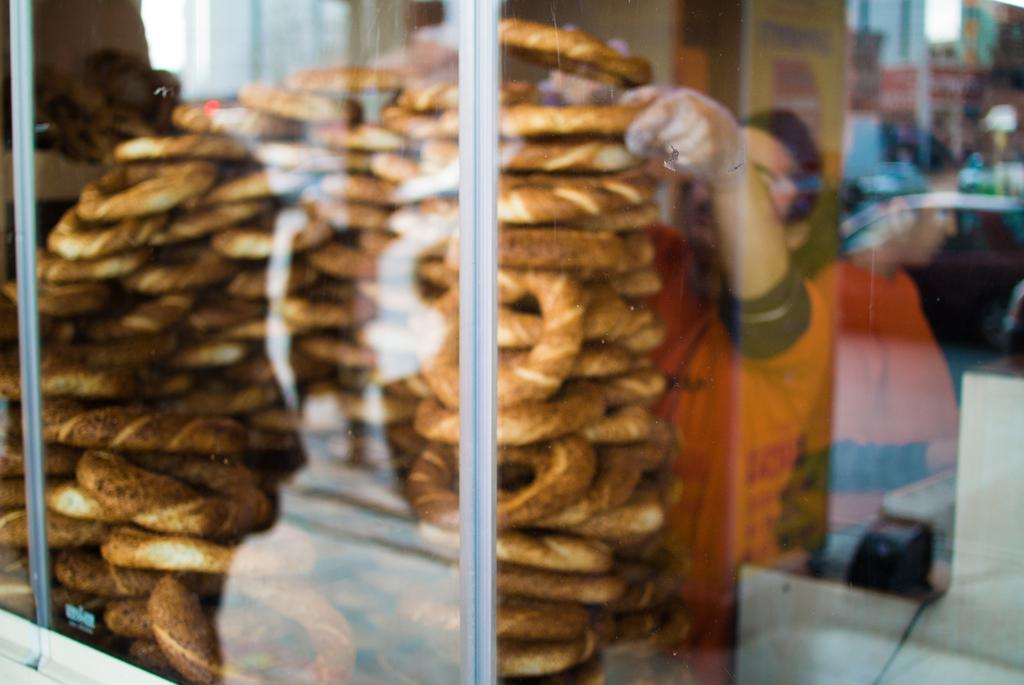What type of food is in the glass container in the image? There are donuts in a glass container in the image. Where is the glass container located in the image? The glass container is on the left side of the image. What is the man in the image doing? The man is arranging donuts. Where is the man located in the image? The man is on the right side of the image. What type of grass is growing on the man's head in the image? There is no grass growing on the man's head in the image. How does the man start arranging the donuts in the image? The image does not show the man starting to arrange the donuts, only the man in the process of arranging them. 